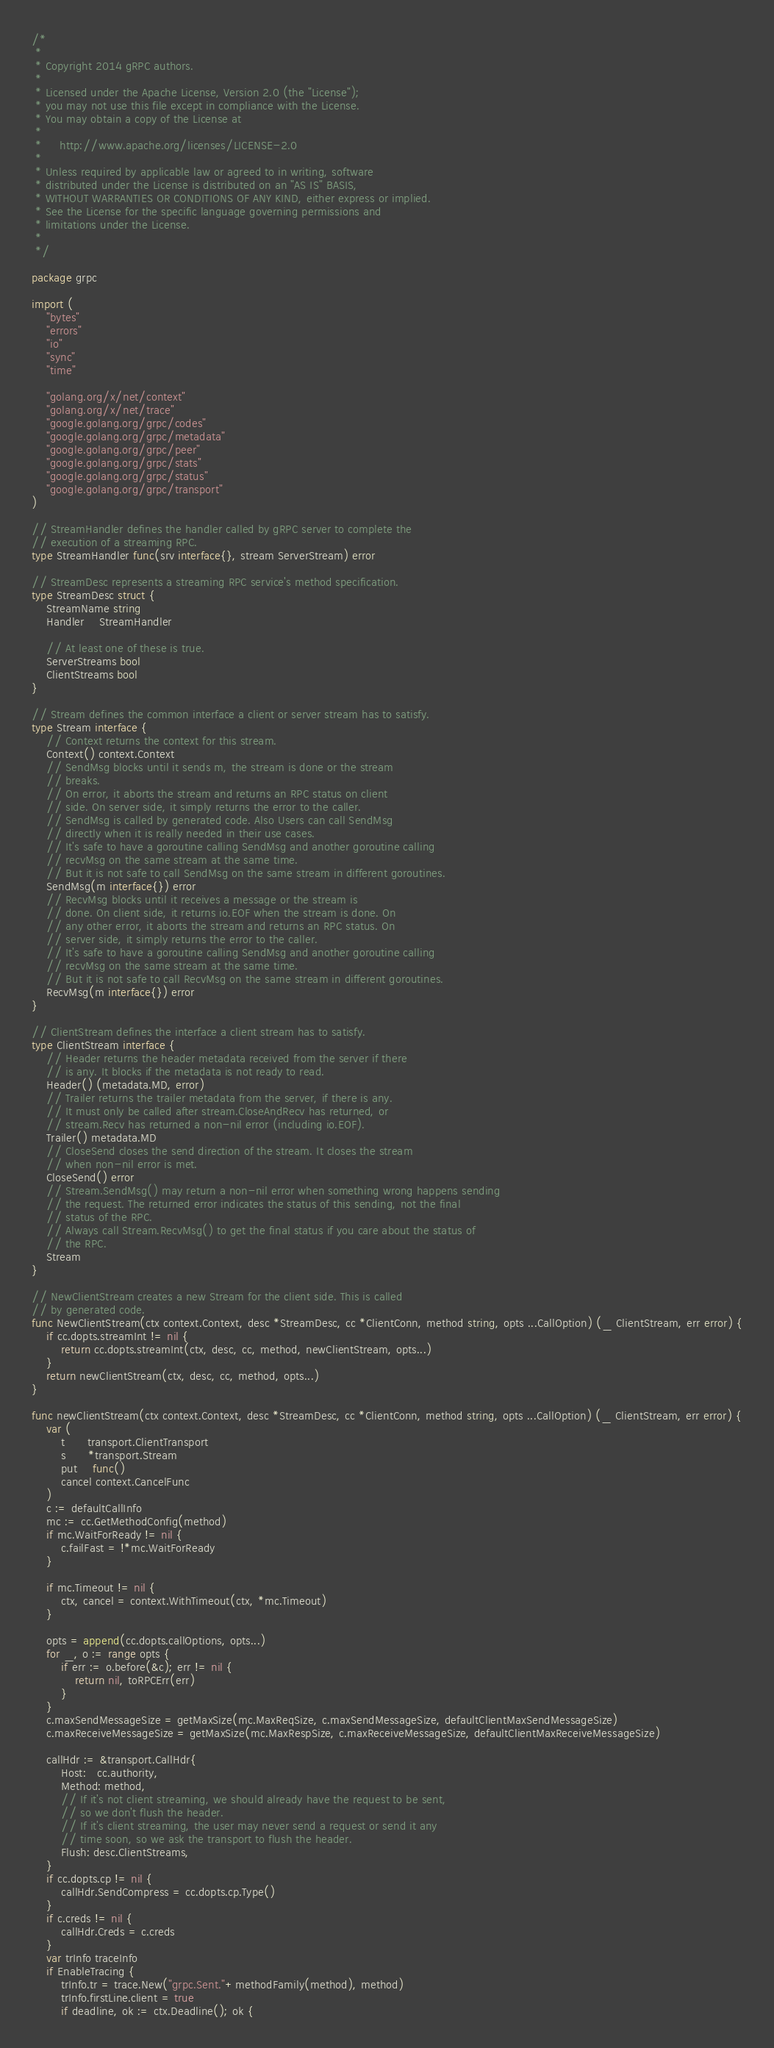<code> <loc_0><loc_0><loc_500><loc_500><_Go_>/*
 *
 * Copyright 2014 gRPC authors.
 *
 * Licensed under the Apache License, Version 2.0 (the "License");
 * you may not use this file except in compliance with the License.
 * You may obtain a copy of the License at
 *
 *     http://www.apache.org/licenses/LICENSE-2.0
 *
 * Unless required by applicable law or agreed to in writing, software
 * distributed under the License is distributed on an "AS IS" BASIS,
 * WITHOUT WARRANTIES OR CONDITIONS OF ANY KIND, either express or implied.
 * See the License for the specific language governing permissions and
 * limitations under the License.
 *
 */

package grpc

import (
	"bytes"
	"errors"
	"io"
	"sync"
	"time"

	"golang.org/x/net/context"
	"golang.org/x/net/trace"
	"google.golang.org/grpc/codes"
	"google.golang.org/grpc/metadata"
	"google.golang.org/grpc/peer"
	"google.golang.org/grpc/stats"
	"google.golang.org/grpc/status"
	"google.golang.org/grpc/transport"
)

// StreamHandler defines the handler called by gRPC server to complete the
// execution of a streaming RPC.
type StreamHandler func(srv interface{}, stream ServerStream) error

// StreamDesc represents a streaming RPC service's method specification.
type StreamDesc struct {
	StreamName string
	Handler    StreamHandler

	// At least one of these is true.
	ServerStreams bool
	ClientStreams bool
}

// Stream defines the common interface a client or server stream has to satisfy.
type Stream interface {
	// Context returns the context for this stream.
	Context() context.Context
	// SendMsg blocks until it sends m, the stream is done or the stream
	// breaks.
	// On error, it aborts the stream and returns an RPC status on client
	// side. On server side, it simply returns the error to the caller.
	// SendMsg is called by generated code. Also Users can call SendMsg
	// directly when it is really needed in their use cases.
	// It's safe to have a goroutine calling SendMsg and another goroutine calling
	// recvMsg on the same stream at the same time.
	// But it is not safe to call SendMsg on the same stream in different goroutines.
	SendMsg(m interface{}) error
	// RecvMsg blocks until it receives a message or the stream is
	// done. On client side, it returns io.EOF when the stream is done. On
	// any other error, it aborts the stream and returns an RPC status. On
	// server side, it simply returns the error to the caller.
	// It's safe to have a goroutine calling SendMsg and another goroutine calling
	// recvMsg on the same stream at the same time.
	// But it is not safe to call RecvMsg on the same stream in different goroutines.
	RecvMsg(m interface{}) error
}

// ClientStream defines the interface a client stream has to satisfy.
type ClientStream interface {
	// Header returns the header metadata received from the server if there
	// is any. It blocks if the metadata is not ready to read.
	Header() (metadata.MD, error)
	// Trailer returns the trailer metadata from the server, if there is any.
	// It must only be called after stream.CloseAndRecv has returned, or
	// stream.Recv has returned a non-nil error (including io.EOF).
	Trailer() metadata.MD
	// CloseSend closes the send direction of the stream. It closes the stream
	// when non-nil error is met.
	CloseSend() error
	// Stream.SendMsg() may return a non-nil error when something wrong happens sending
	// the request. The returned error indicates the status of this sending, not the final
	// status of the RPC.
	// Always call Stream.RecvMsg() to get the final status if you care about the status of
	// the RPC.
	Stream
}

// NewClientStream creates a new Stream for the client side. This is called
// by generated code.
func NewClientStream(ctx context.Context, desc *StreamDesc, cc *ClientConn, method string, opts ...CallOption) (_ ClientStream, err error) {
	if cc.dopts.streamInt != nil {
		return cc.dopts.streamInt(ctx, desc, cc, method, newClientStream, opts...)
	}
	return newClientStream(ctx, desc, cc, method, opts...)
}

func newClientStream(ctx context.Context, desc *StreamDesc, cc *ClientConn, method string, opts ...CallOption) (_ ClientStream, err error) {
	var (
		t      transport.ClientTransport
		s      *transport.Stream
		put    func()
		cancel context.CancelFunc
	)
	c := defaultCallInfo
	mc := cc.GetMethodConfig(method)
	if mc.WaitForReady != nil {
		c.failFast = !*mc.WaitForReady
	}

	if mc.Timeout != nil {
		ctx, cancel = context.WithTimeout(ctx, *mc.Timeout)
	}

	opts = append(cc.dopts.callOptions, opts...)
	for _, o := range opts {
		if err := o.before(&c); err != nil {
			return nil, toRPCErr(err)
		}
	}
	c.maxSendMessageSize = getMaxSize(mc.MaxReqSize, c.maxSendMessageSize, defaultClientMaxSendMessageSize)
	c.maxReceiveMessageSize = getMaxSize(mc.MaxRespSize, c.maxReceiveMessageSize, defaultClientMaxReceiveMessageSize)

	callHdr := &transport.CallHdr{
		Host:   cc.authority,
		Method: method,
		// If it's not client streaming, we should already have the request to be sent,
		// so we don't flush the header.
		// If it's client streaming, the user may never send a request or send it any
		// time soon, so we ask the transport to flush the header.
		Flush: desc.ClientStreams,
	}
	if cc.dopts.cp != nil {
		callHdr.SendCompress = cc.dopts.cp.Type()
	}
	if c.creds != nil {
		callHdr.Creds = c.creds
	}
	var trInfo traceInfo
	if EnableTracing {
		trInfo.tr = trace.New("grpc.Sent."+methodFamily(method), method)
		trInfo.firstLine.client = true
		if deadline, ok := ctx.Deadline(); ok {</code> 